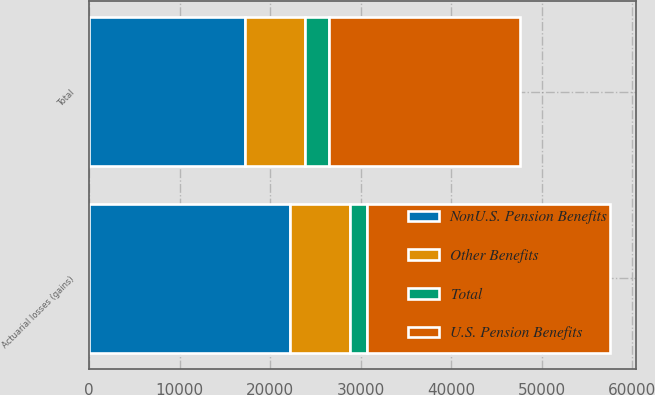Convert chart. <chart><loc_0><loc_0><loc_500><loc_500><stacked_bar_chart><ecel><fcel>Actuarial losses (gains)<fcel>Total<nl><fcel>Other Benefits<fcel>6555<fcel>6555<nl><fcel>NonU.S. Pension Benefits<fcel>22236<fcel>17252<nl><fcel>Total<fcel>1895<fcel>2674<nl><fcel>U.S. Pension Benefits<fcel>26896<fcel>21133<nl></chart> 